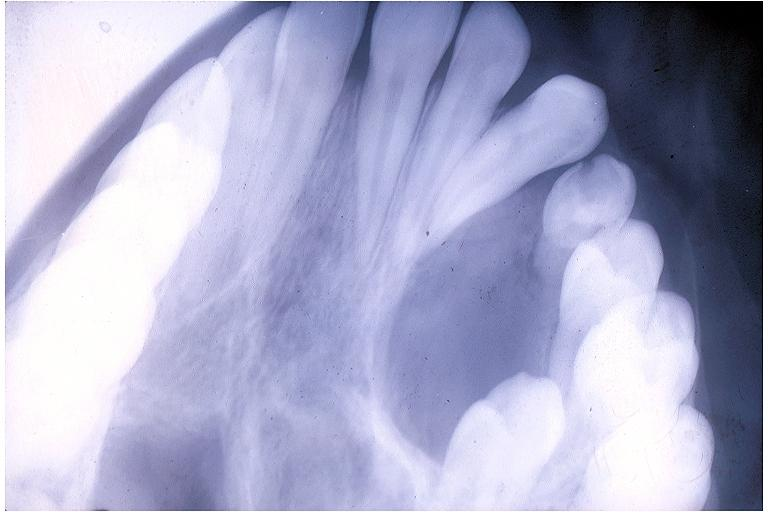what is present?
Answer the question using a single word or phrase. Oral 